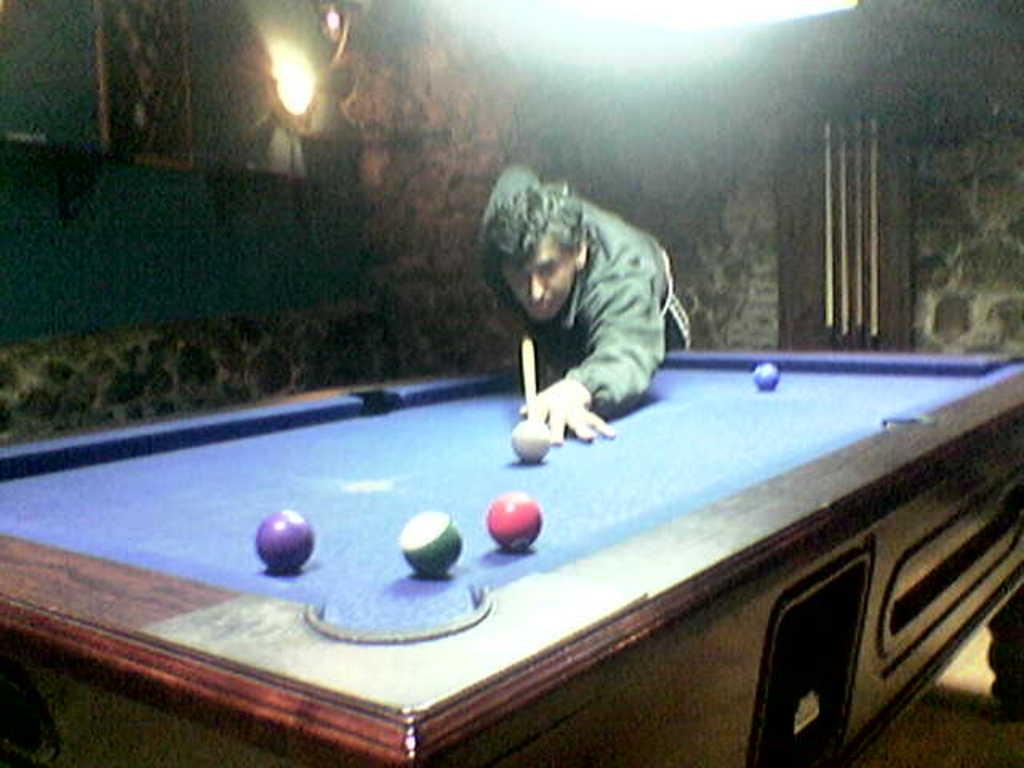What is the person in the image doing? The person is standing and holding a stick in the image. What is in front of the person? There is a table in front of the person. What objects are on or near the table? There are balls on or near the table. What can be seen in the background of the image? There is a wall in the background of the image. What type of quill is the person using to write on the wall in the image? There is no quill or writing on the wall present in the image. How many hens are visible in the image? There are no hens visible in the image. 